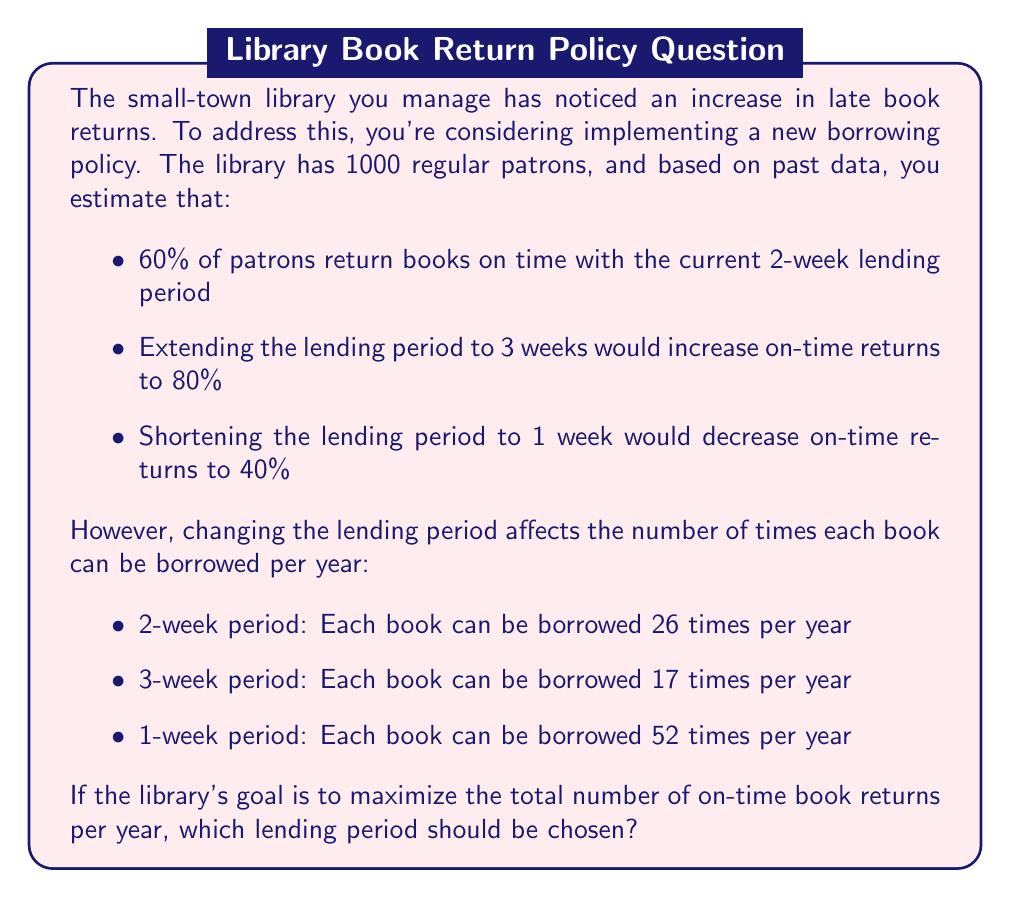Solve this math problem. Let's approach this step-by-step:

1) First, we need to calculate the number of on-time returns per year for each lending period option.

2) For each option, we'll multiply:
   (Number of patrons) × (Percentage of on-time returns) × (Number of borrowings per year)

3) 2-week period (current):
   $1000 \times 0.60 \times 26 = 15,600$ on-time returns per year

4) 3-week period:
   $1000 \times 0.80 \times 17 = 13,600$ on-time returns per year

5) 1-week period:
   $1000 \times 0.40 \times 52 = 20,800$ on-time returns per year

6) We can represent this mathematically as an optimization problem:

   Let $T$ be the number of on-time returns per year
   Let $x$ be the lending period in weeks

   Then:
   $$T(x) = \begin{cases} 
   20,800 & \text{if } x = 1 \\
   15,600 & \text{if } x = 2 \\
   13,600 & \text{if } x = 3
   \end{cases}$$

7) To maximize $T$, we choose the largest value, which is 20,800, corresponding to $x = 1$.
Answer: The 1-week lending period should be chosen, as it maximizes the total number of on-time book returns per year at 20,800. 